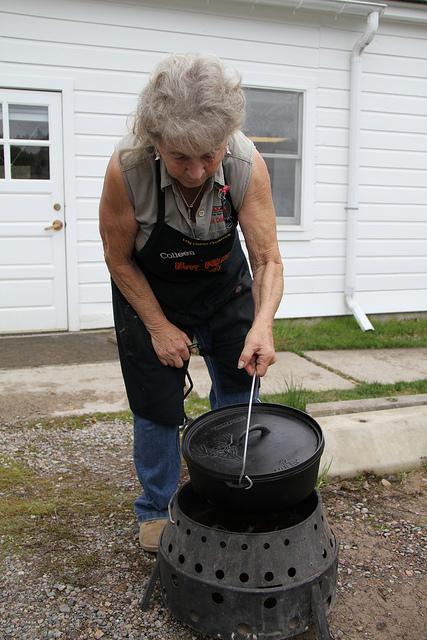What is this man doing?
Short answer required. Cooking. Is that house run-down?
Be succinct. No. Is the woman hungry?
Short answer required. Yes. 